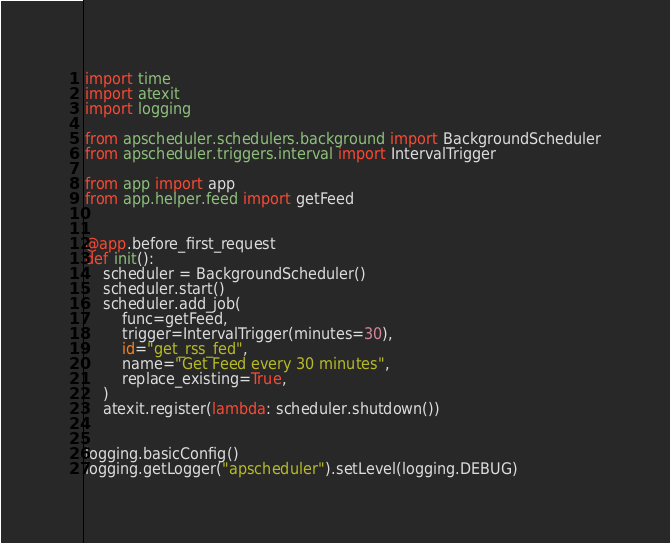<code> <loc_0><loc_0><loc_500><loc_500><_Python_>import time
import atexit
import logging

from apscheduler.schedulers.background import BackgroundScheduler
from apscheduler.triggers.interval import IntervalTrigger

from app import app
from app.helper.feed import getFeed


@app.before_first_request
def init():
    scheduler = BackgroundScheduler()
    scheduler.start()
    scheduler.add_job(
        func=getFeed,
        trigger=IntervalTrigger(minutes=30),
        id="get_rss_fed",
        name="Get Feed every 30 minutes",
        replace_existing=True,
    )
    atexit.register(lambda: scheduler.shutdown())


logging.basicConfig()
logging.getLogger("apscheduler").setLevel(logging.DEBUG)
</code> 